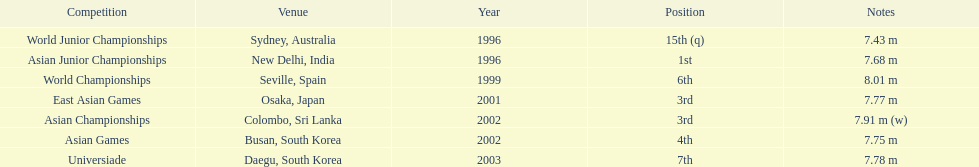Which year was his best jump? 1999. Could you parse the entire table as a dict? {'header': ['Competition', 'Venue', 'Year', 'Position', 'Notes'], 'rows': [['World Junior Championships', 'Sydney, Australia', '1996', '15th (q)', '7.43 m'], ['Asian Junior Championships', 'New Delhi, India', '1996', '1st', '7.68 m'], ['World Championships', 'Seville, Spain', '1999', '6th', '8.01 m'], ['East Asian Games', 'Osaka, Japan', '2001', '3rd', '7.77 m'], ['Asian Championships', 'Colombo, Sri Lanka', '2002', '3rd', '7.91 m (w)'], ['Asian Games', 'Busan, South Korea', '2002', '4th', '7.75 m'], ['Universiade', 'Daegu, South Korea', '2003', '7th', '7.78 m']]} 